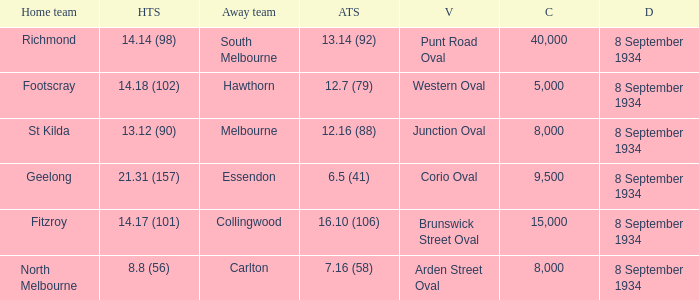When the Home team scored 14.14 (98), what did the Away Team score? 13.14 (92). 